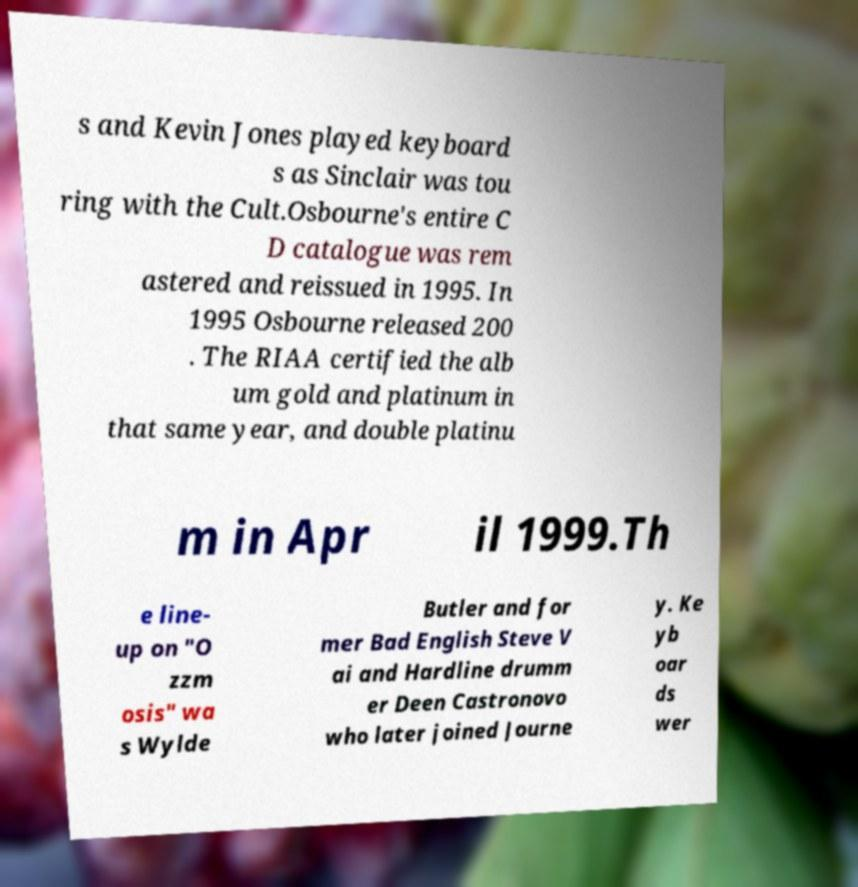Please read and relay the text visible in this image. What does it say? s and Kevin Jones played keyboard s as Sinclair was tou ring with the Cult.Osbourne's entire C D catalogue was rem astered and reissued in 1995. In 1995 Osbourne released 200 . The RIAA certified the alb um gold and platinum in that same year, and double platinu m in Apr il 1999.Th e line- up on "O zzm osis" wa s Wylde Butler and for mer Bad English Steve V ai and Hardline drumm er Deen Castronovo who later joined Journe y. Ke yb oar ds wer 